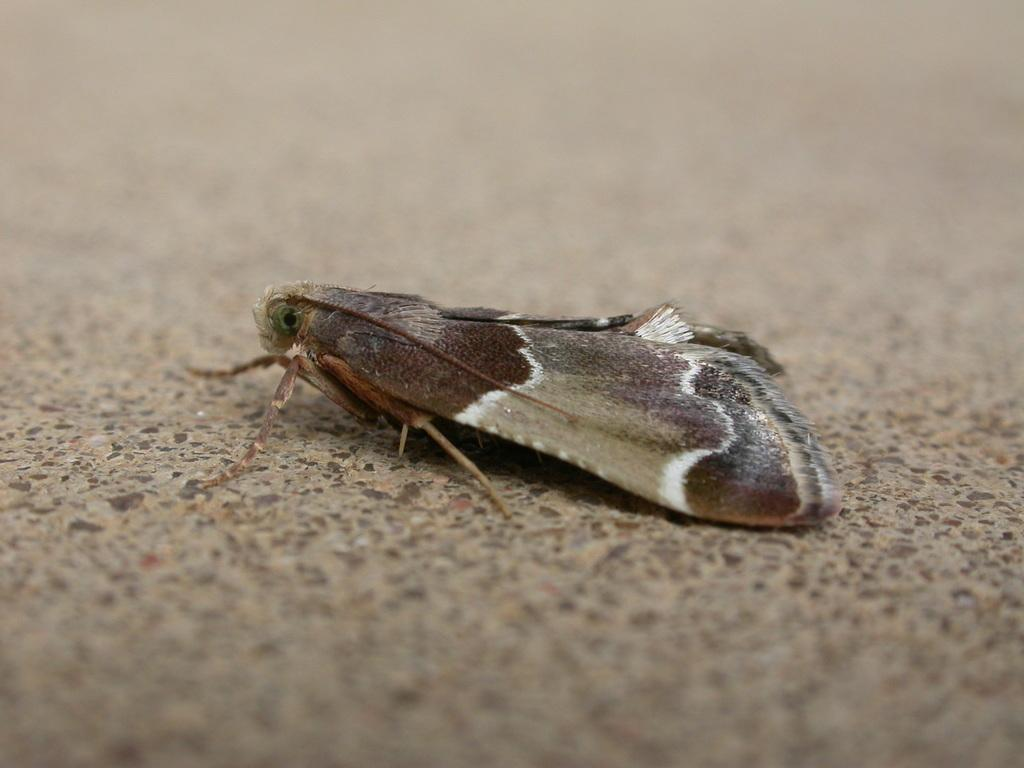What type of creature is present in the image? There is an insect in the image. Where is the insect located in the image? The insect is on the surface. What level of difficulty is the insect designed for in the image? The image does not provide information about the difficulty level of the insect. What is the insect's stomach doing in the image? The image does not provide information about the insect's stomach. 